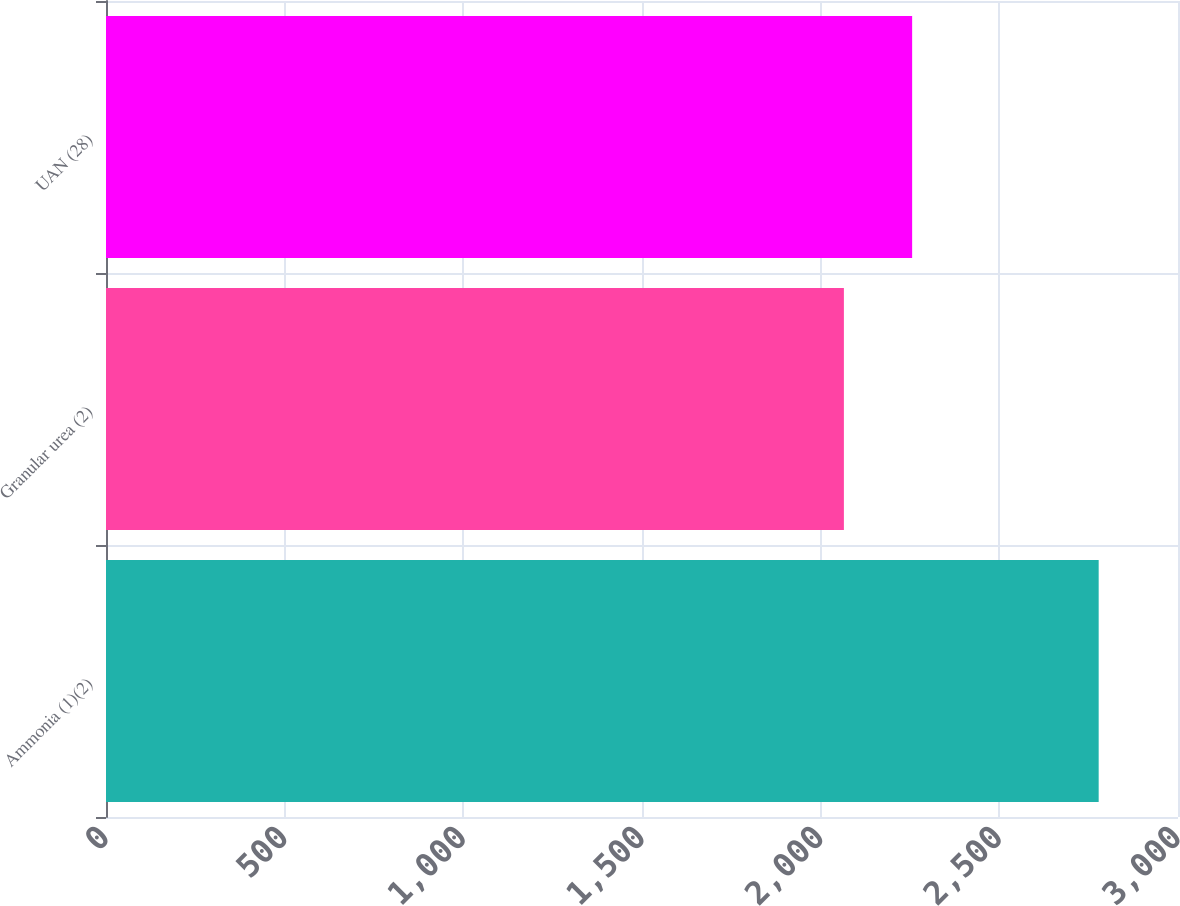Convert chart. <chart><loc_0><loc_0><loc_500><loc_500><bar_chart><fcel>Ammonia (1)(2)<fcel>Granular urea (2)<fcel>UAN (28)<nl><fcel>2778<fcel>2065<fcel>2256<nl></chart> 